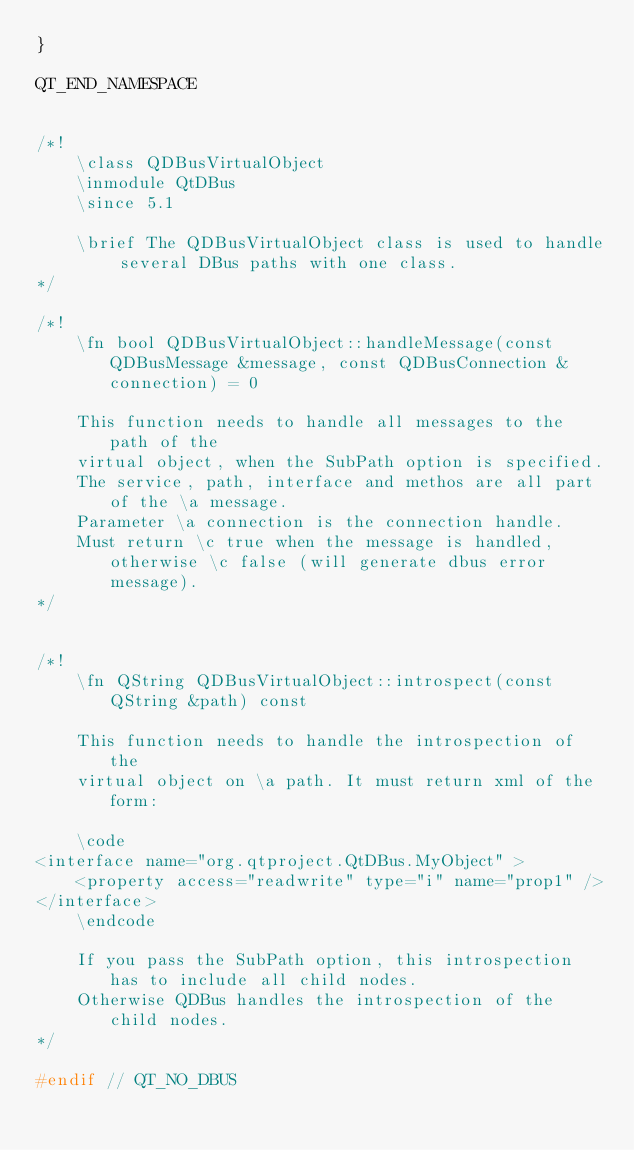<code> <loc_0><loc_0><loc_500><loc_500><_C++_>}

QT_END_NAMESPACE


/*!
    \class QDBusVirtualObject
    \inmodule QtDBus
    \since 5.1

    \brief The QDBusVirtualObject class is used to handle several DBus paths with one class.
*/

/*!
    \fn bool QDBusVirtualObject::handleMessage(const QDBusMessage &message, const QDBusConnection &connection) = 0

    This function needs to handle all messages to the path of the
    virtual object, when the SubPath option is specified.
    The service, path, interface and methos are all part of the \a message.
    Parameter \a connection is the connection handle.
    Must return \c true when the message is handled, otherwise \c false (will generate dbus error message).
*/


/*!
    \fn QString QDBusVirtualObject::introspect(const QString &path) const

    This function needs to handle the introspection of the
    virtual object on \a path. It must return xml of the form:

    \code
<interface name="org.qtproject.QtDBus.MyObject" >
    <property access="readwrite" type="i" name="prop1" />
</interface>
    \endcode

    If you pass the SubPath option, this introspection has to include all child nodes.
    Otherwise QDBus handles the introspection of the child nodes.
*/

#endif // QT_NO_DBUS
</code> 